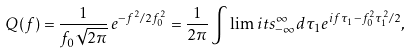<formula> <loc_0><loc_0><loc_500><loc_500>Q ( f ) = \frac { 1 } { f _ { 0 } \sqrt { 2 \pi } } \, e ^ { - f ^ { 2 } / 2 f _ { 0 } ^ { 2 } } = \frac { 1 } { 2 \pi } \int \lim i t s _ { - \infty } ^ { \infty } d \tau _ { 1 } e ^ { i f \tau _ { 1 } - f _ { 0 } ^ { 2 } \tau _ { 1 } ^ { 2 } / 2 } ,</formula> 